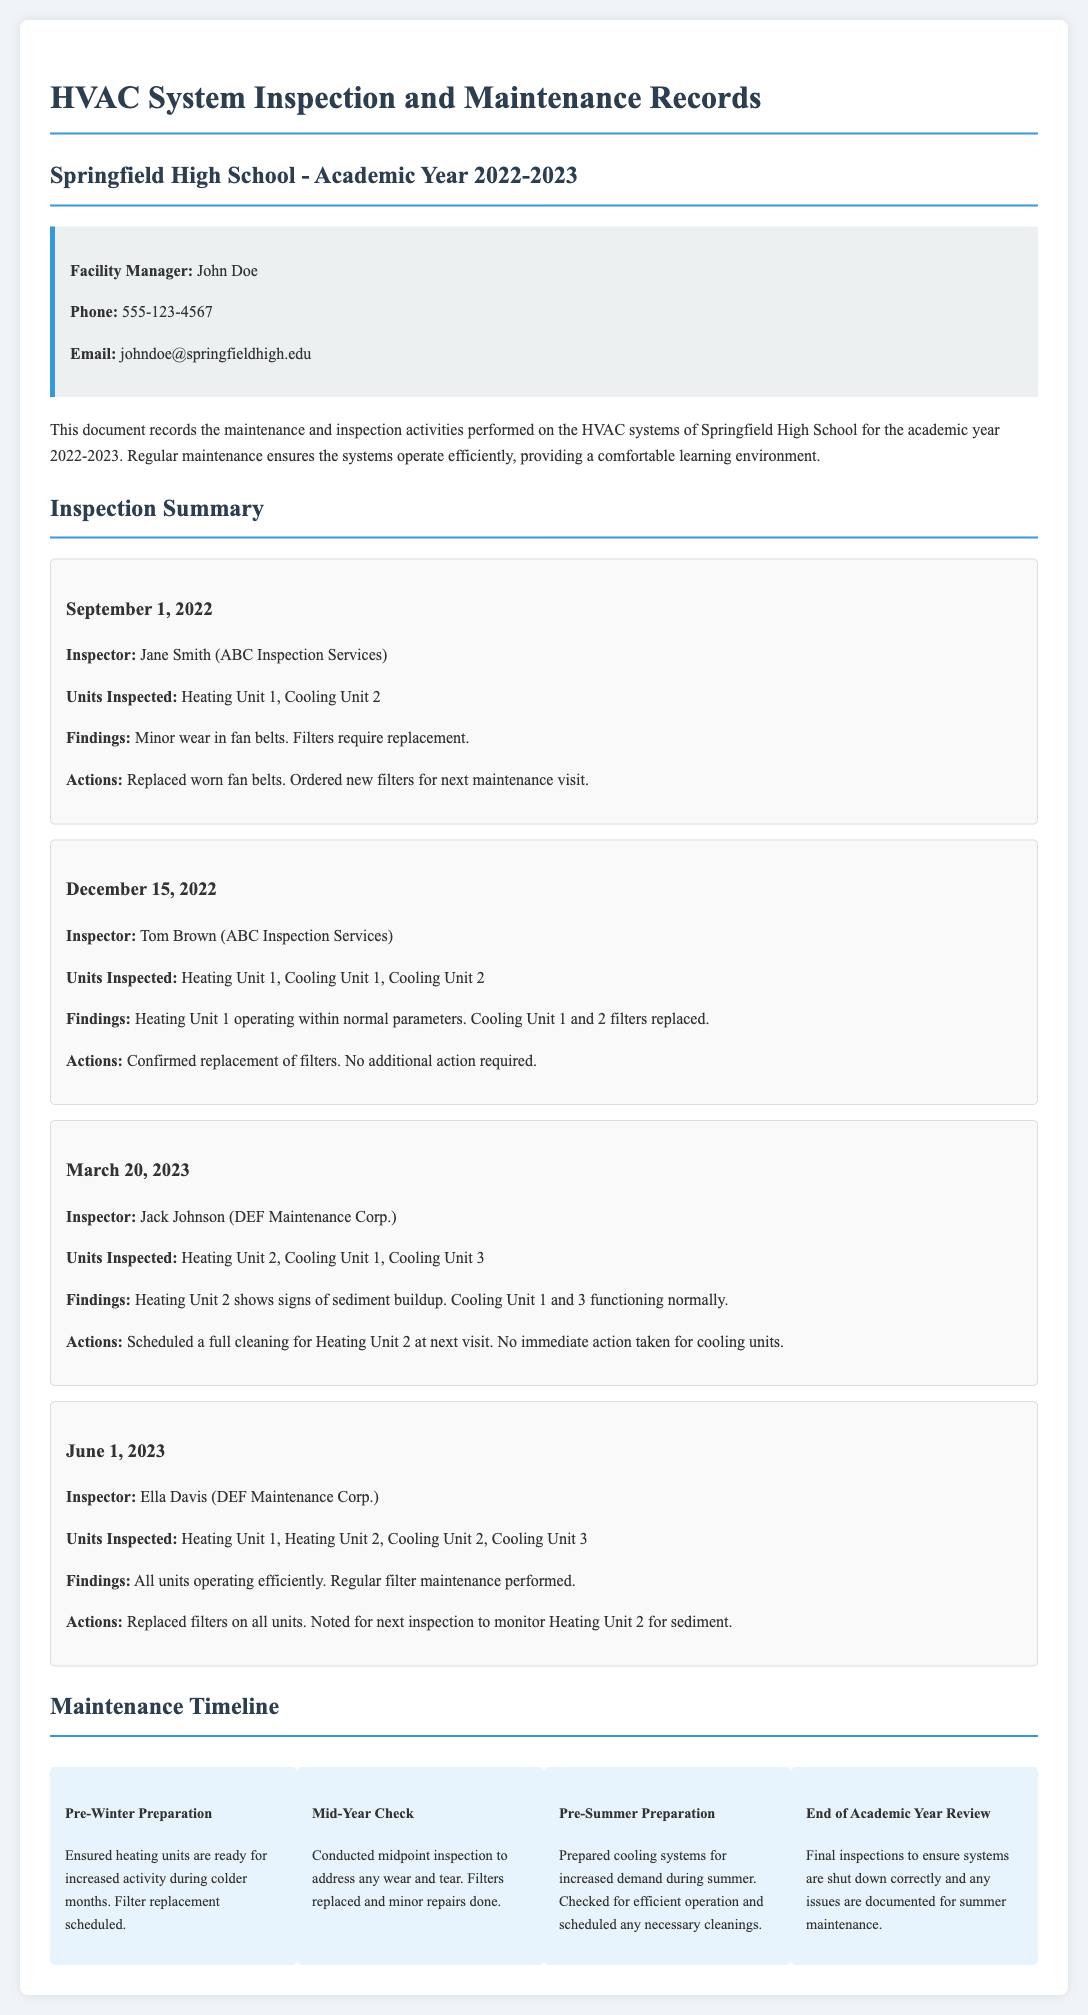What is the name of the facility manager? The name of the facility manager is listed at the beginning of the document under the Facility Manager section.
Answer: John Doe How many units were inspected on March 20, 2023? The number of units inspected is mentioned in the inspection entry dated March 20, 2023.
Answer: 3 What was identified as needing cleaning in the March 20, 2023 inspection? The specific issue that needed addressing is found in the findings of the March 20, 2023 inspection.
Answer: Heating Unit 2 When was the last inspection conducted? The date of the last inspection is provided in the entry for June 1, 2023.
Answer: June 1, 2023 What action was taken on September 1, 2022? The actions taken are detailed in the inspection entry for September 1, 2022.
Answer: Replaced worn fan belts List one of the items noted for monitoring during the June 1, 2023 inspection. The documentation mentions items to monitor in the actions section of the June 1, 2023 inspection.
Answer: Heating Unit 2 for sediment What type of inspection was performed after mid-year? The type of inspection is stated in the maintenance timeline section that discusses actions taken at specific times of the year.
Answer: Mid-Year Check How many cooling units were inspected on December 15, 2022? The total number of cooling units inspected is indicated in the inspection entry dated December 15, 2022.
Answer: 2 